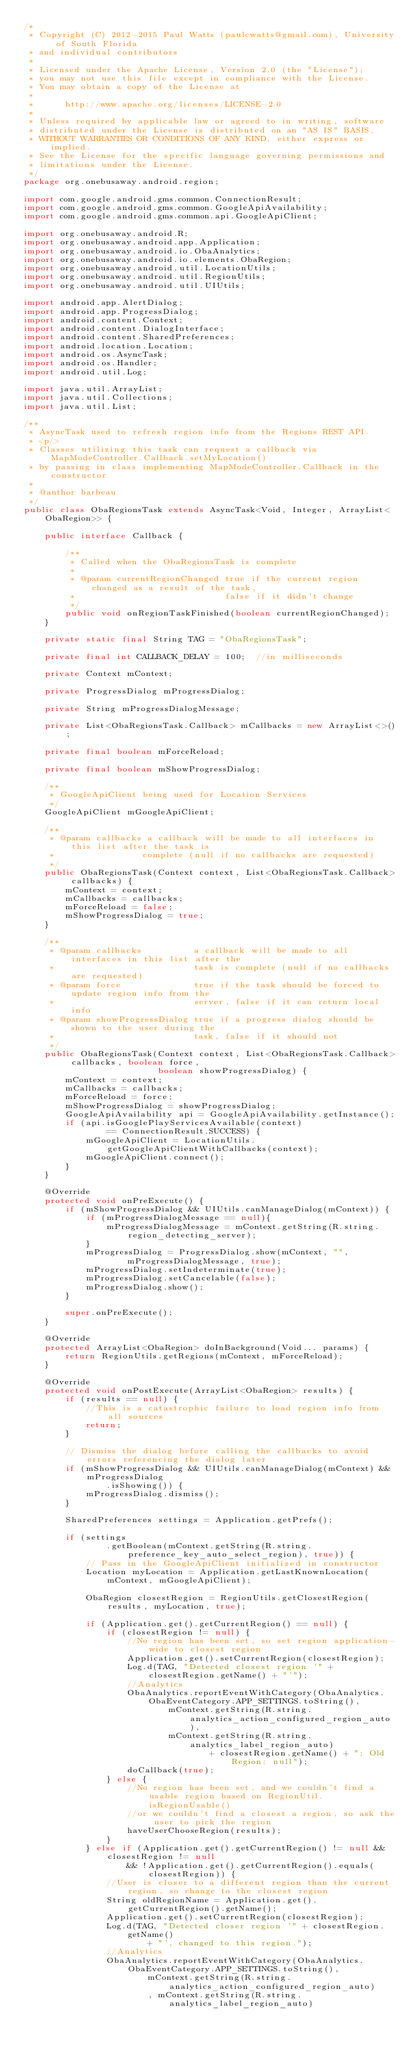Convert code to text. <code><loc_0><loc_0><loc_500><loc_500><_Java_>/*
 * Copyright (C) 2012-2015 Paul Watts (paulcwatts@gmail.com), University of South Florida
 * and individual contributors
 *
 * Licensed under the Apache License, Version 2.0 (the "License");
 * you may not use this file except in compliance with the License.
 * You may obtain a copy of the License at
 *
 *      http://www.apache.org/licenses/LICENSE-2.0
 *
 * Unless required by applicable law or agreed to in writing, software
 * distributed under the License is distributed on an "AS IS" BASIS,
 * WITHOUT WARRANTIES OR CONDITIONS OF ANY KIND, either express or implied.
 * See the License for the specific language governing permissions and
 * limitations under the License.
 */
package org.onebusaway.android.region;

import com.google.android.gms.common.ConnectionResult;
import com.google.android.gms.common.GoogleApiAvailability;
import com.google.android.gms.common.api.GoogleApiClient;

import org.onebusaway.android.R;
import org.onebusaway.android.app.Application;
import org.onebusaway.android.io.ObaAnalytics;
import org.onebusaway.android.io.elements.ObaRegion;
import org.onebusaway.android.util.LocationUtils;
import org.onebusaway.android.util.RegionUtils;
import org.onebusaway.android.util.UIUtils;

import android.app.AlertDialog;
import android.app.ProgressDialog;
import android.content.Context;
import android.content.DialogInterface;
import android.content.SharedPreferences;
import android.location.Location;
import android.os.AsyncTask;
import android.os.Handler;
import android.util.Log;

import java.util.ArrayList;
import java.util.Collections;
import java.util.List;

/**
 * AsyncTask used to refresh region info from the Regions REST API.
 * <p/>
 * Classes utilizing this task can request a callback via MapModeController.Callback.setMyLocation()
 * by passing in class implementing MapModeController.Callback in the constructor
 *
 * @author barbeau
 */
public class ObaRegionsTask extends AsyncTask<Void, Integer, ArrayList<ObaRegion>> {

    public interface Callback {

        /**
         * Called when the ObaRegionsTask is complete
         *
         * @param currentRegionChanged true if the current region changed as a result of the task,
         *                             false if it didn't change
         */
        public void onRegionTaskFinished(boolean currentRegionChanged);
    }

    private static final String TAG = "ObaRegionsTask";

    private final int CALLBACK_DELAY = 100;  //in milliseconds

    private Context mContext;

    private ProgressDialog mProgressDialog;

    private String mProgressDialogMessage;

    private List<ObaRegionsTask.Callback> mCallbacks = new ArrayList<>();

    private final boolean mForceReload;

    private final boolean mShowProgressDialog;

    /**
     * GoogleApiClient being used for Location Services
     */
    GoogleApiClient mGoogleApiClient;

    /**
     * @param callbacks a callback will be made to all interfaces in this list after the task is
     *                 complete (null if no callbacks are requested)
     */
    public ObaRegionsTask(Context context, List<ObaRegionsTask.Callback> callbacks) {
        mContext = context;
        mCallbacks = callbacks;
        mForceReload = false;
        mShowProgressDialog = true;
    }

    /**
     * @param callbacks          a callback will be made to all interfaces in this list after the
     *                           task is complete (null if no callbacks are requested)
     * @param force              true if the task should be forced to update region info from the
     *                           server, false if it can return local info
     * @param showProgressDialog true if a progress dialog should be shown to the user during the
     *                           task, false if it should not
     */
    public ObaRegionsTask(Context context, List<ObaRegionsTask.Callback> callbacks, boolean force,
                          boolean showProgressDialog) {
        mContext = context;
        mCallbacks = callbacks;
        mForceReload = force;
        mShowProgressDialog = showProgressDialog;
        GoogleApiAvailability api = GoogleApiAvailability.getInstance();
        if (api.isGooglePlayServicesAvailable(context)
                == ConnectionResult.SUCCESS) {
            mGoogleApiClient = LocationUtils.getGoogleApiClientWithCallbacks(context);
            mGoogleApiClient.connect();
        }
    }

    @Override
    protected void onPreExecute() {
        if (mShowProgressDialog && UIUtils.canManageDialog(mContext)) {
            if (mProgressDialogMessage == null){
                mProgressDialogMessage = mContext.getString(R.string.region_detecting_server);
            }
            mProgressDialog = ProgressDialog.show(mContext, "",
                    mProgressDialogMessage, true);
            mProgressDialog.setIndeterminate(true);
            mProgressDialog.setCancelable(false);
            mProgressDialog.show();
        }

        super.onPreExecute();
    }

    @Override
    protected ArrayList<ObaRegion> doInBackground(Void... params) {
        return RegionUtils.getRegions(mContext, mForceReload);
    }

    @Override
    protected void onPostExecute(ArrayList<ObaRegion> results) {
        if (results == null) {
            //This is a catastrophic failure to load region info from all sources
            return;
        }

        // Dismiss the dialog before calling the callbacks to avoid errors referencing the dialog later
        if (mShowProgressDialog && UIUtils.canManageDialog(mContext) && mProgressDialog
                .isShowing()) {
            mProgressDialog.dismiss();
        }

        SharedPreferences settings = Application.getPrefs();

        if (settings
                .getBoolean(mContext.getString(R.string.preference_key_auto_select_region), true)) {
            // Pass in the GoogleApiClient initialized in constructor
            Location myLocation = Application.getLastKnownLocation(mContext, mGoogleApiClient);

            ObaRegion closestRegion = RegionUtils.getClosestRegion(results, myLocation, true);

            if (Application.get().getCurrentRegion() == null) {
                if (closestRegion != null) {
                    //No region has been set, so set region application-wide to closest region
                    Application.get().setCurrentRegion(closestRegion);
                    Log.d(TAG, "Detected closest region '" + closestRegion.getName() + "'");
                    //Analytics
                    ObaAnalytics.reportEventWithCategory(ObaAnalytics.ObaEventCategory.APP_SETTINGS.toString(),
                            mContext.getString(R.string.analytics_action_configured_region_auto),
                            mContext.getString(R.string.analytics_label_region_auto)
                                    + closestRegion.getName() + "; Old Region: null");
                    doCallback(true);
                } else {
                    //No region has been set, and we couldn't find a usable region based on RegionUtil.isRegionUsable()
                    //or we couldn't find a closest a region, so ask the user to pick the region
                    haveUserChooseRegion(results);
                }
            } else if (Application.get().getCurrentRegion() != null && closestRegion != null
                    && !Application.get().getCurrentRegion().equals(closestRegion)) {
                //User is closer to a different region than the current region, so change to the closest region
                String oldRegionName = Application.get().getCurrentRegion().getName();
                Application.get().setCurrentRegion(closestRegion);
                Log.d(TAG, "Detected closer region '" + closestRegion.getName()
                        + "', changed to this region.");
                //Analytics
                ObaAnalytics.reportEventWithCategory(ObaAnalytics.ObaEventCategory.APP_SETTINGS.toString(),
                        mContext.getString(R.string.analytics_action_configured_region_auto)
                        , mContext.getString(R.string.analytics_label_region_auto)</code> 